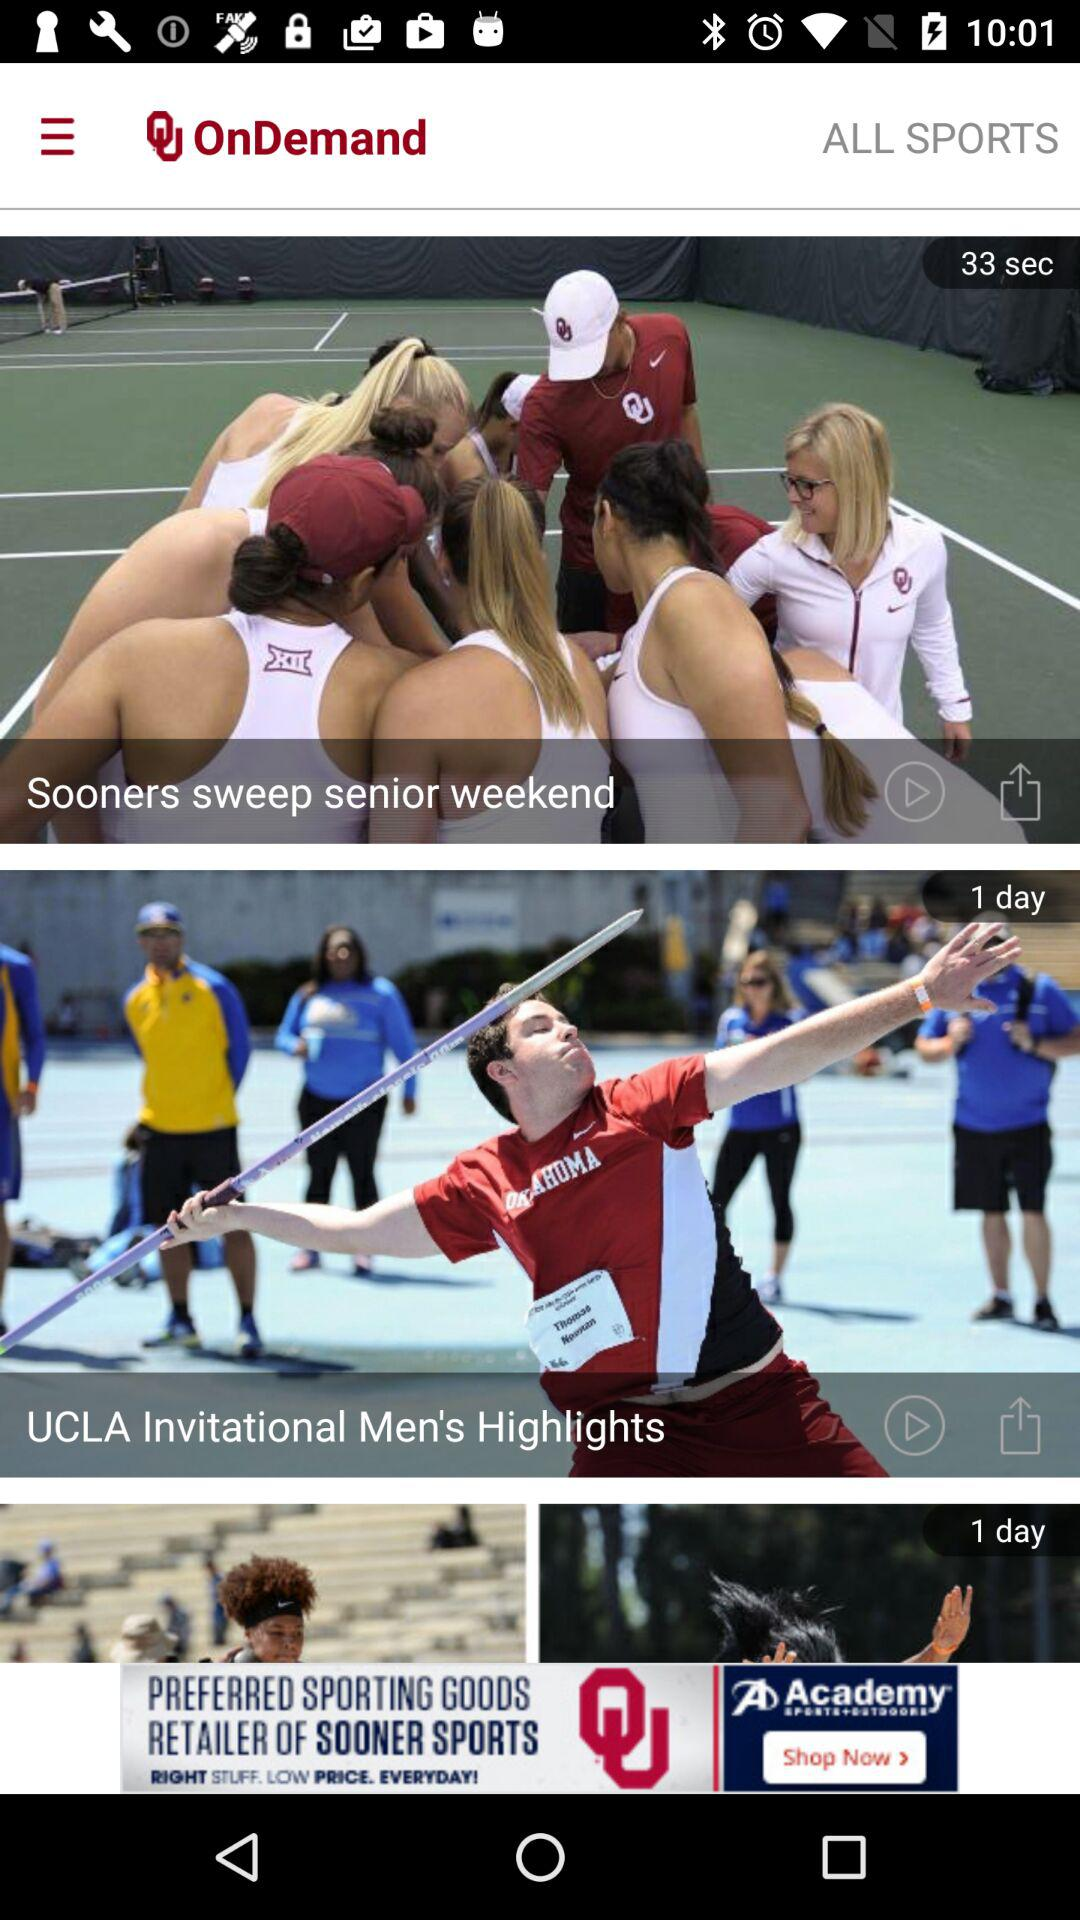How many seconds ago was the video "Sooners sweep senior weekend" uploaded? The video "Sooners sweep senior weekend" was uploaded 33 seconds ago. 